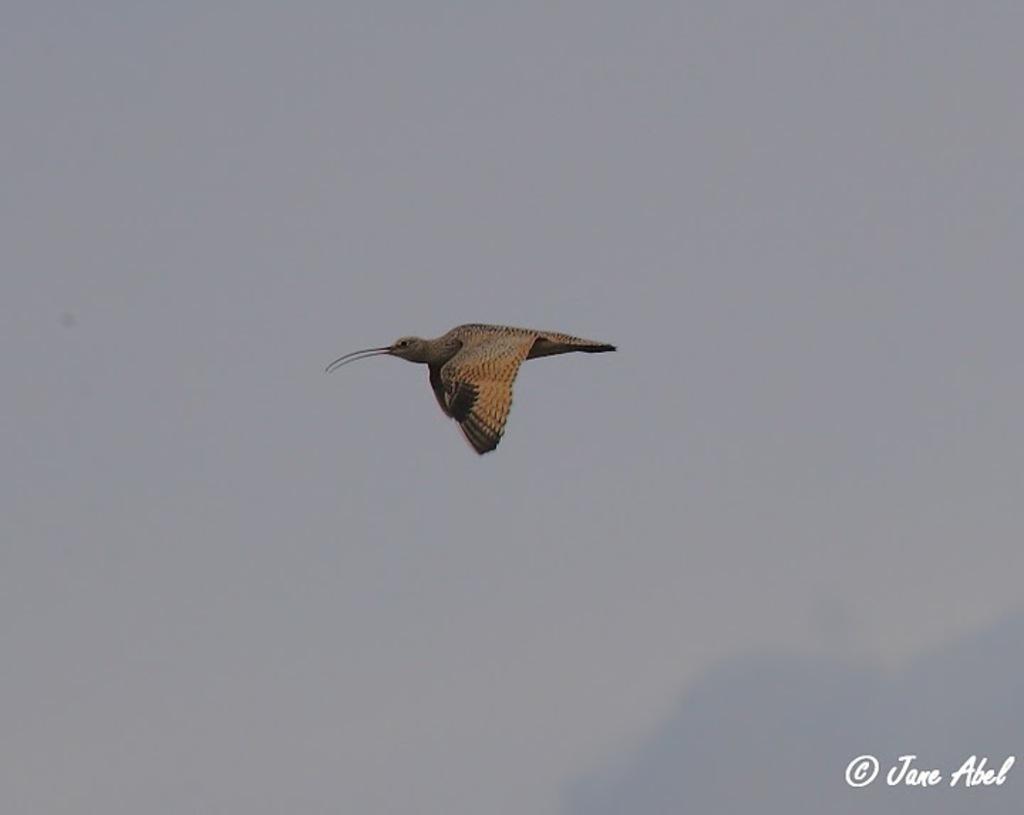In one or two sentences, can you explain what this image depicts? In this picture we can see a bird flying in the sky and at the bottom right corner we can see text. 